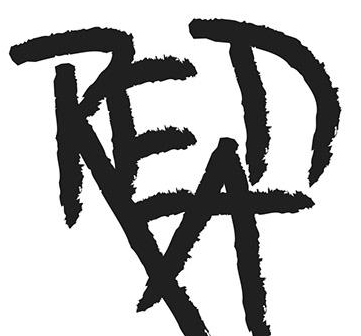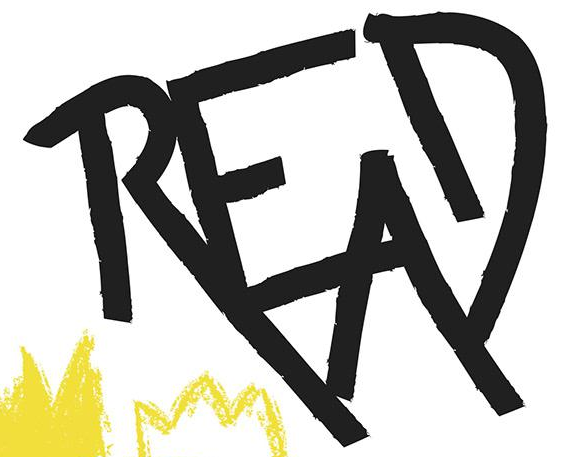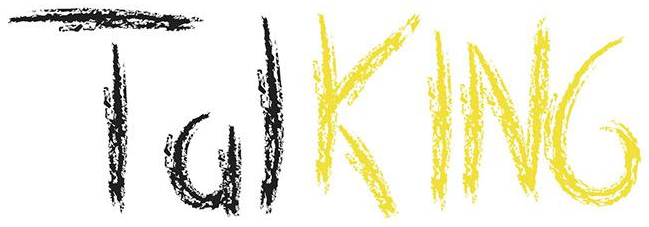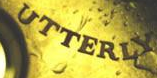What words can you see in these images in sequence, separated by a semicolon? READ; READ; TalKING; UTTERLY 